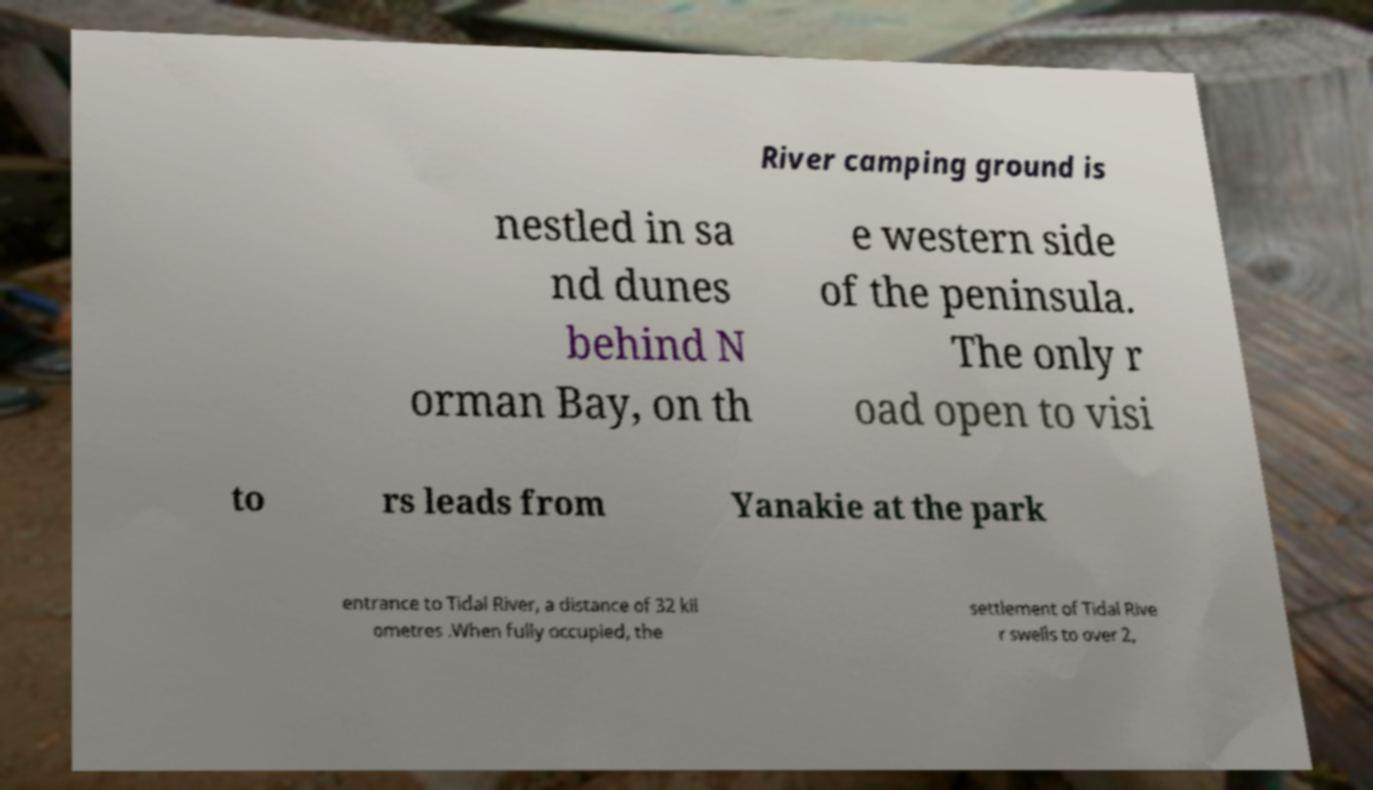Could you assist in decoding the text presented in this image and type it out clearly? River camping ground is nestled in sa nd dunes behind N orman Bay, on th e western side of the peninsula. The only r oad open to visi to rs leads from Yanakie at the park entrance to Tidal River, a distance of 32 kil ometres .When fully occupied, the settlement of Tidal Rive r swells to over 2, 